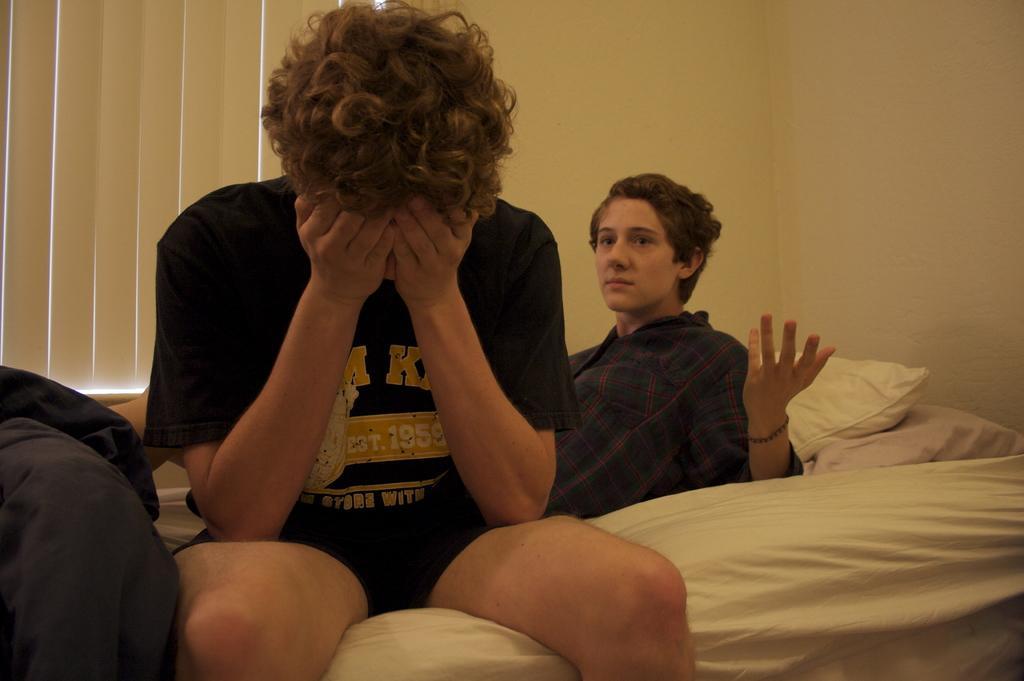Describe this image in one or two sentences. In this image we can see two persons of them one is lying on the cot and the other is sitting on the cot. In the background we can see blankets, blinds and walls. 